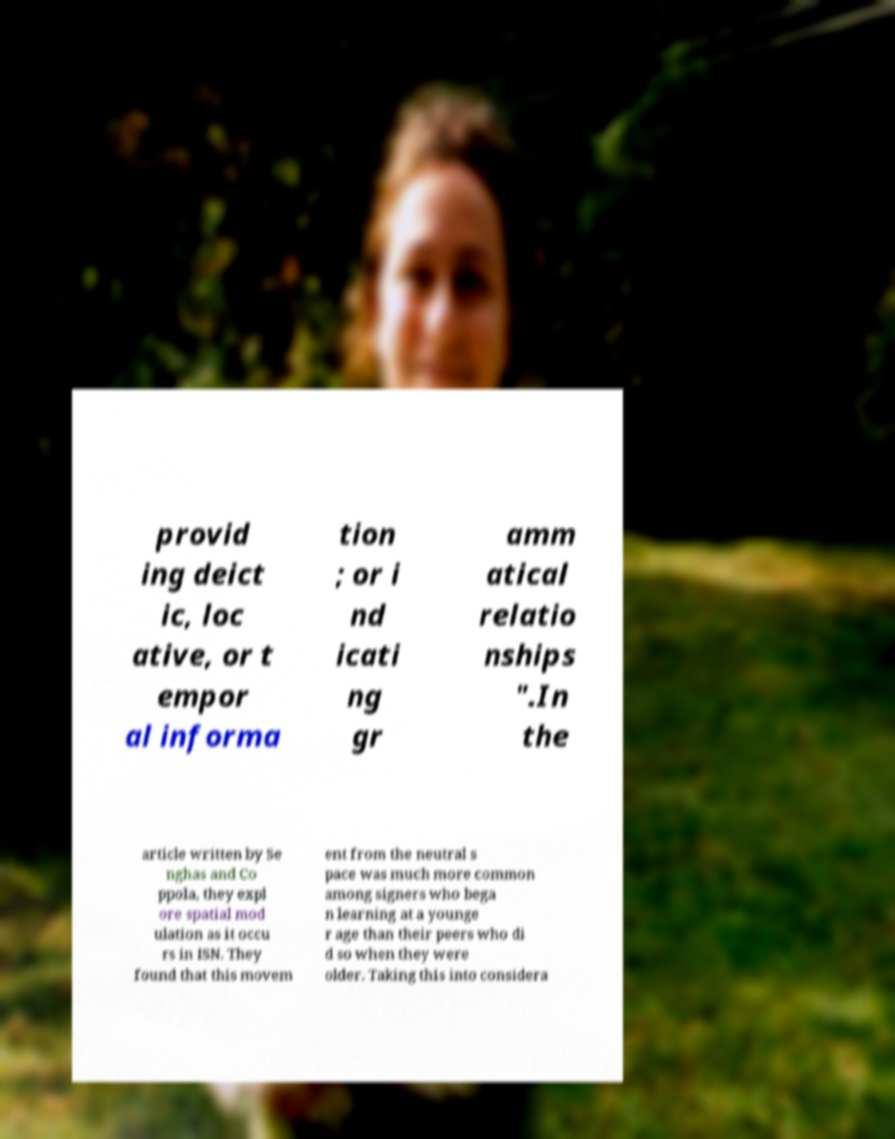Can you read and provide the text displayed in the image?This photo seems to have some interesting text. Can you extract and type it out for me? provid ing deict ic, loc ative, or t empor al informa tion ; or i nd icati ng gr amm atical relatio nships ".In the article written by Se nghas and Co ppola, they expl ore spatial mod ulation as it occu rs in ISN. They found that this movem ent from the neutral s pace was much more common among signers who bega n learning at a younge r age than their peers who di d so when they were older. Taking this into considera 